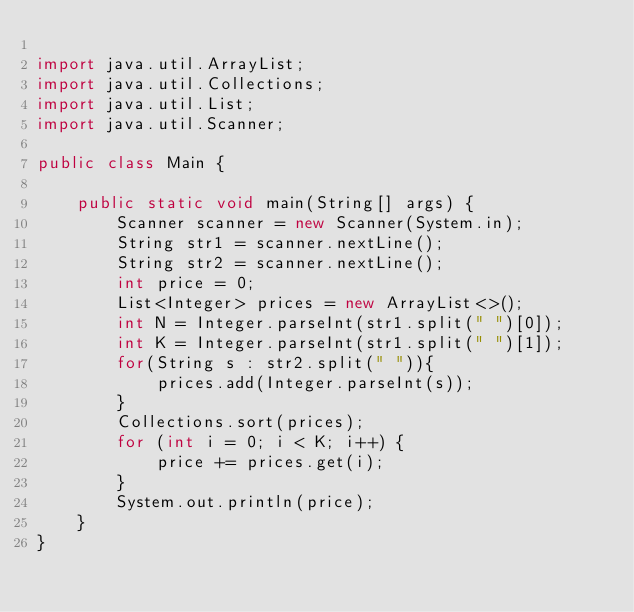Convert code to text. <code><loc_0><loc_0><loc_500><loc_500><_Java_>
import java.util.ArrayList;
import java.util.Collections;
import java.util.List;
import java.util.Scanner;

public class Main {

    public static void main(String[] args) {
        Scanner scanner = new Scanner(System.in);
        String str1 = scanner.nextLine();
        String str2 = scanner.nextLine();
        int price = 0;
        List<Integer> prices = new ArrayList<>();
        int N = Integer.parseInt(str1.split(" ")[0]);
        int K = Integer.parseInt(str1.split(" ")[1]);
        for(String s : str2.split(" ")){
            prices.add(Integer.parseInt(s));
        }
        Collections.sort(prices);
        for (int i = 0; i < K; i++) {
            price += prices.get(i);
        }
        System.out.println(price);
    }
}</code> 